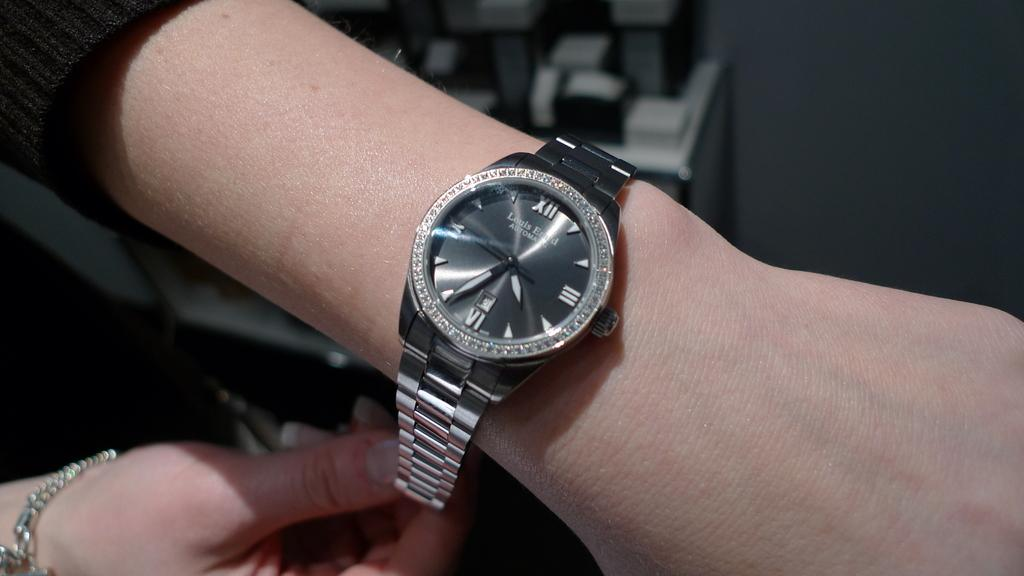<image>
Summarize the visual content of the image. A black wrist watch shows the time is 4:34. 